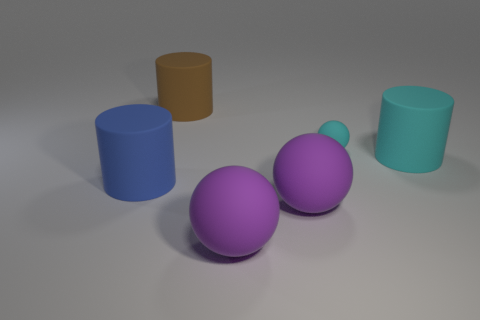Do the small thing and the rubber thing that is right of the small rubber thing have the same color?
Provide a short and direct response. Yes. How many cubes are either blue matte objects or big brown rubber objects?
Ensure brevity in your answer.  0. Are there any other things that have the same color as the tiny rubber thing?
Offer a very short reply. Yes. Is the big brown object made of the same material as the ball behind the blue matte thing?
Offer a very short reply. Yes. What number of objects are big rubber cylinders behind the blue rubber object or large brown cylinders?
Keep it short and to the point. 2. Is there a big rubber object of the same color as the tiny rubber thing?
Offer a very short reply. Yes. There is a brown object; does it have the same shape as the cyan object that is behind the big cyan rubber cylinder?
Your response must be concise. No. How many big rubber cylinders are on the left side of the cyan matte cylinder and in front of the brown thing?
Your answer should be very brief. 1. There is a brown thing that is the same shape as the big blue thing; what is its material?
Your response must be concise. Rubber. What size is the cyan object on the right side of the sphere behind the large blue cylinder?
Make the answer very short. Large. 